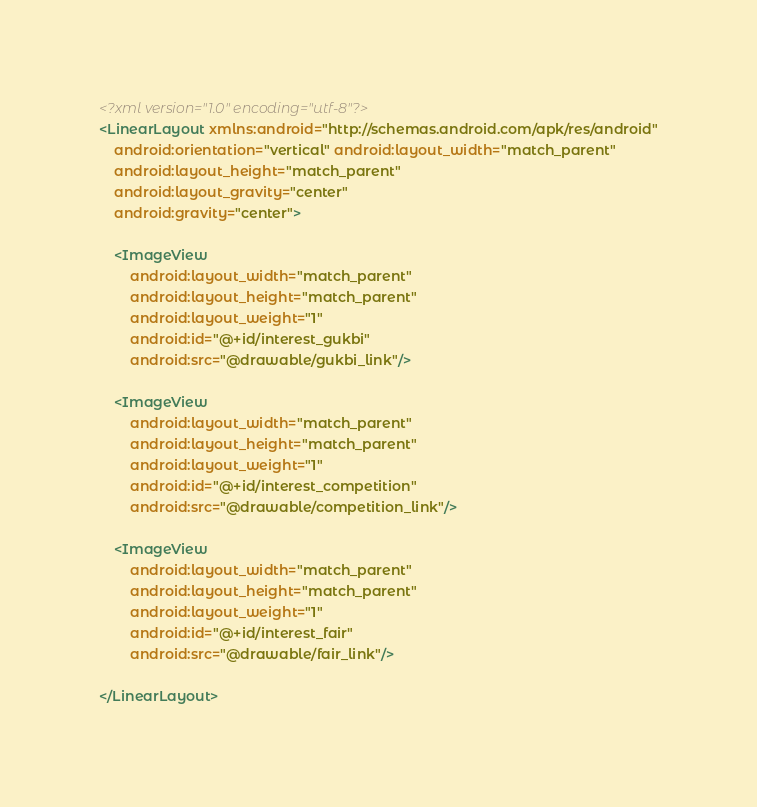<code> <loc_0><loc_0><loc_500><loc_500><_XML_><?xml version="1.0" encoding="utf-8"?>
<LinearLayout xmlns:android="http://schemas.android.com/apk/res/android"
    android:orientation="vertical" android:layout_width="match_parent"
    android:layout_height="match_parent"
    android:layout_gravity="center"
    android:gravity="center">

    <ImageView
        android:layout_width="match_parent"
        android:layout_height="match_parent"
        android:layout_weight="1"
        android:id="@+id/interest_gukbi"
        android:src="@drawable/gukbi_link"/>

    <ImageView
        android:layout_width="match_parent"
        android:layout_height="match_parent"
        android:layout_weight="1"
        android:id="@+id/interest_competition"
        android:src="@drawable/competition_link"/>

    <ImageView
        android:layout_width="match_parent"
        android:layout_height="match_parent"
        android:layout_weight="1"
        android:id="@+id/interest_fair"
        android:src="@drawable/fair_link"/>

</LinearLayout></code> 